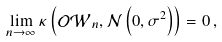<formula> <loc_0><loc_0><loc_500><loc_500>\lim _ { n \to \infty } \kappa \left ( \mathcal { O W } _ { n } , \mathcal { N } \left ( 0 , \sigma ^ { 2 } \right ) \right ) = 0 \, ,</formula> 